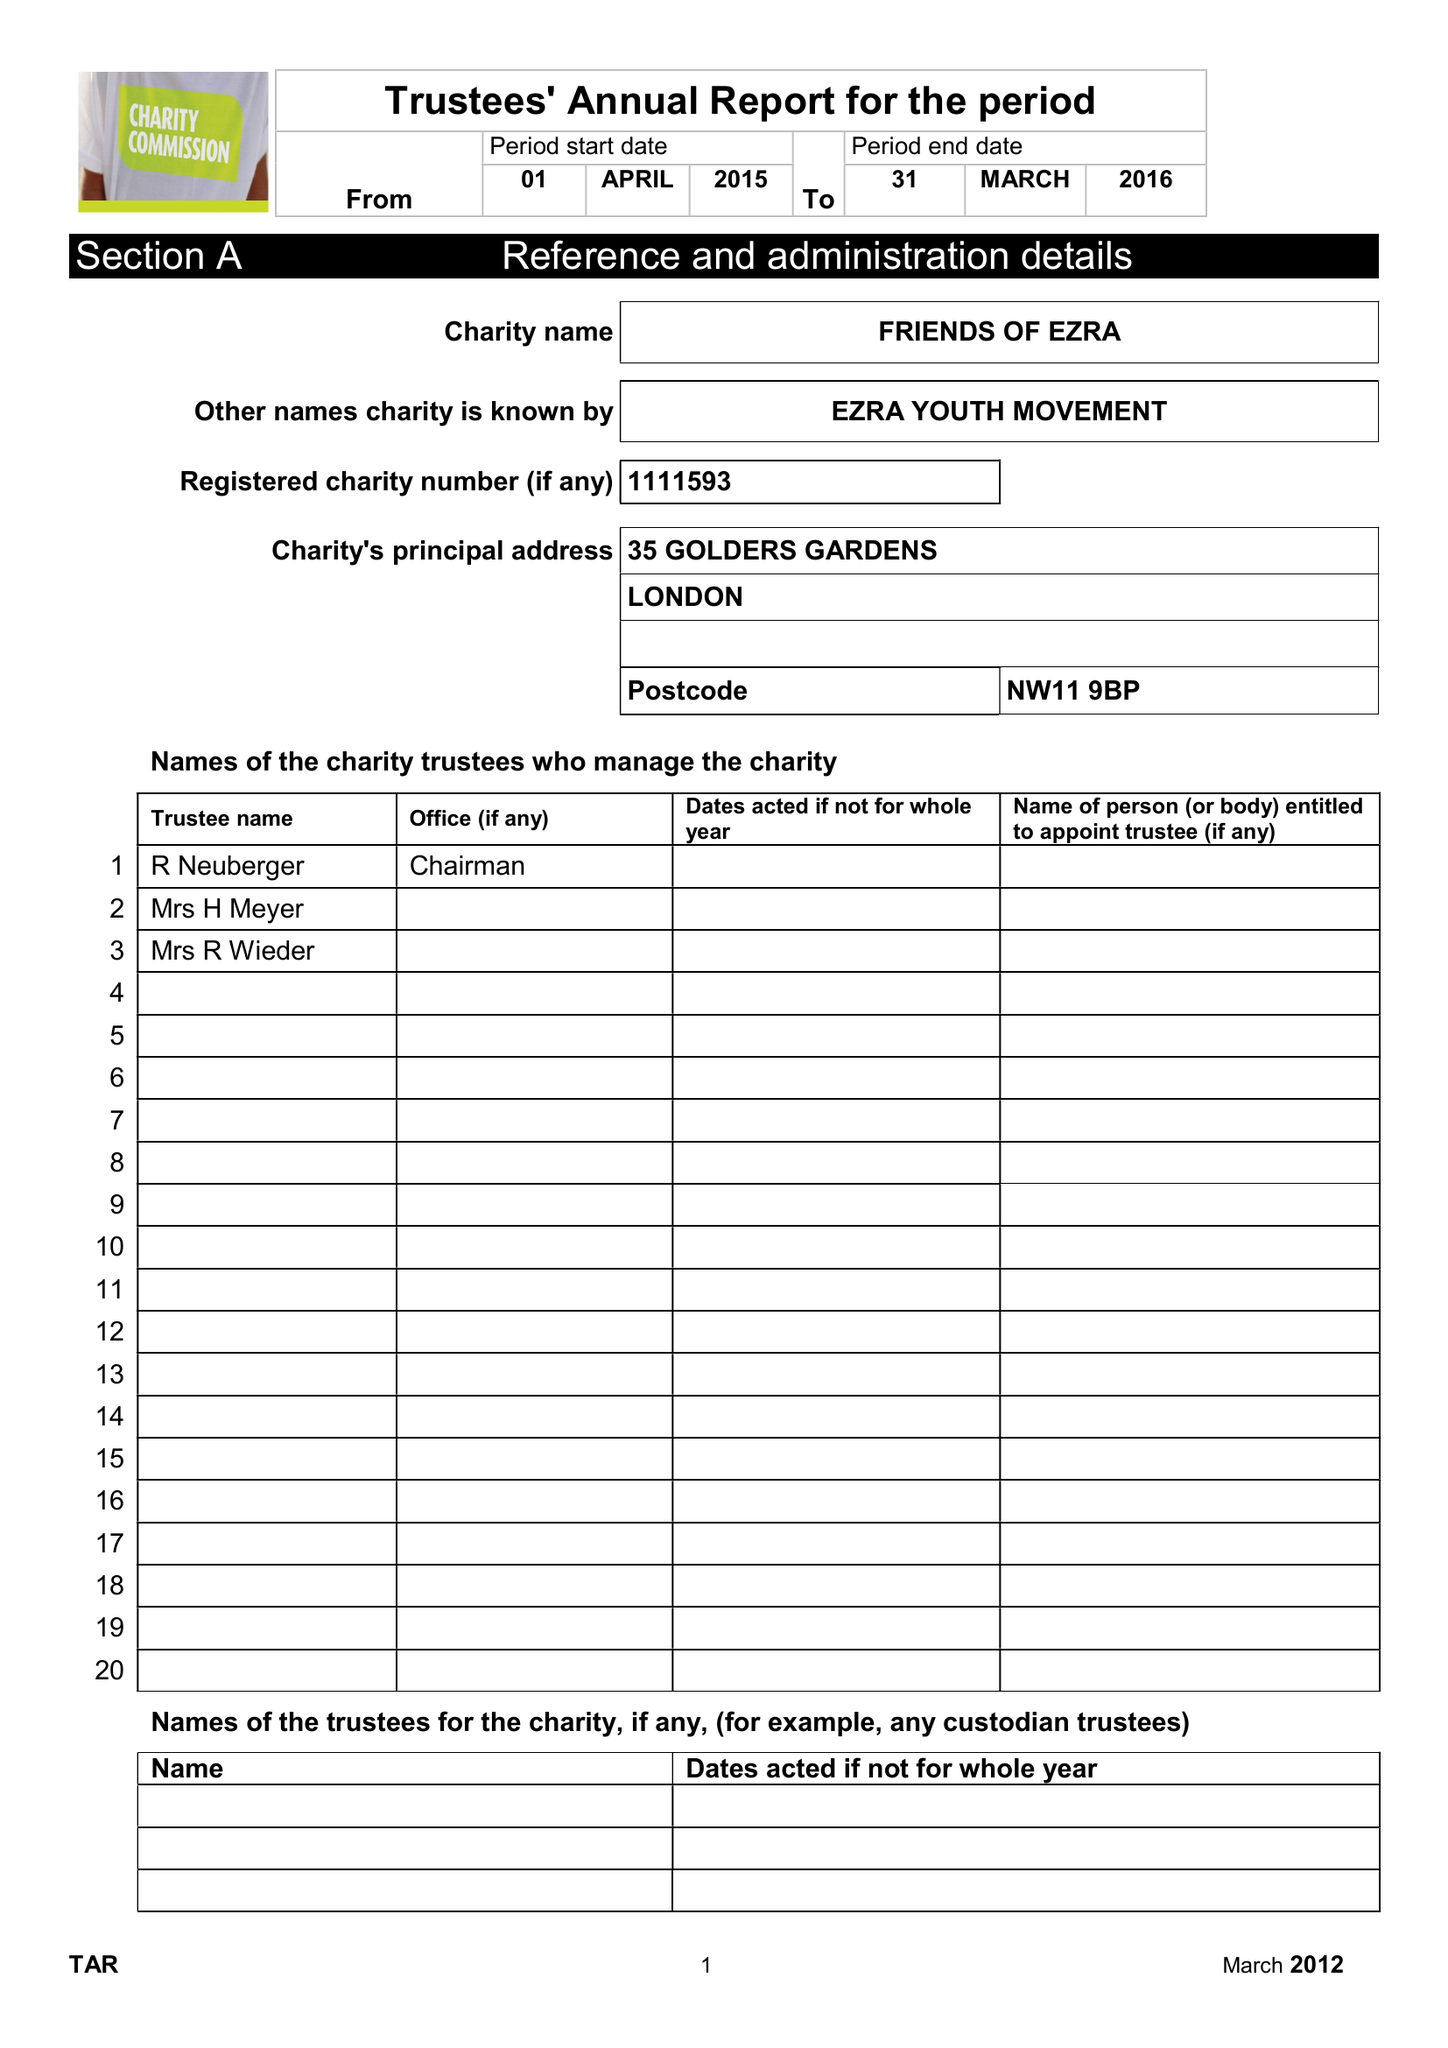What is the value for the charity_name?
Answer the question using a single word or phrase. Friends Of Ezra 